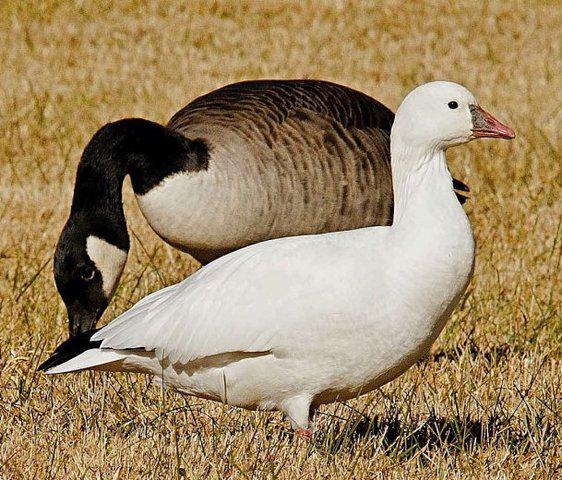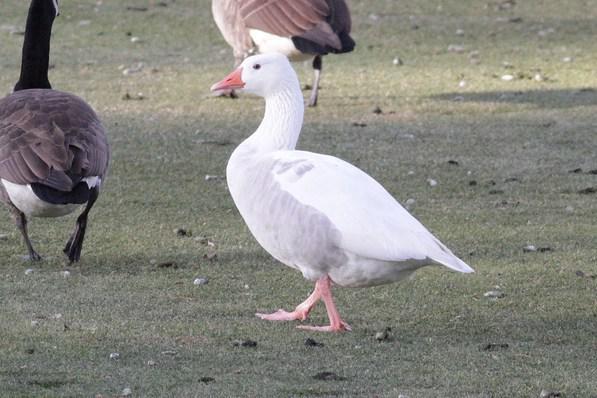The first image is the image on the left, the second image is the image on the right. Examine the images to the left and right. Is the description "There is one white duck in front of any other ducks facing right." accurate? Answer yes or no. Yes. The first image is the image on the left, the second image is the image on the right. Given the left and right images, does the statement "There are 6 or more completely white geese." hold true? Answer yes or no. No. 